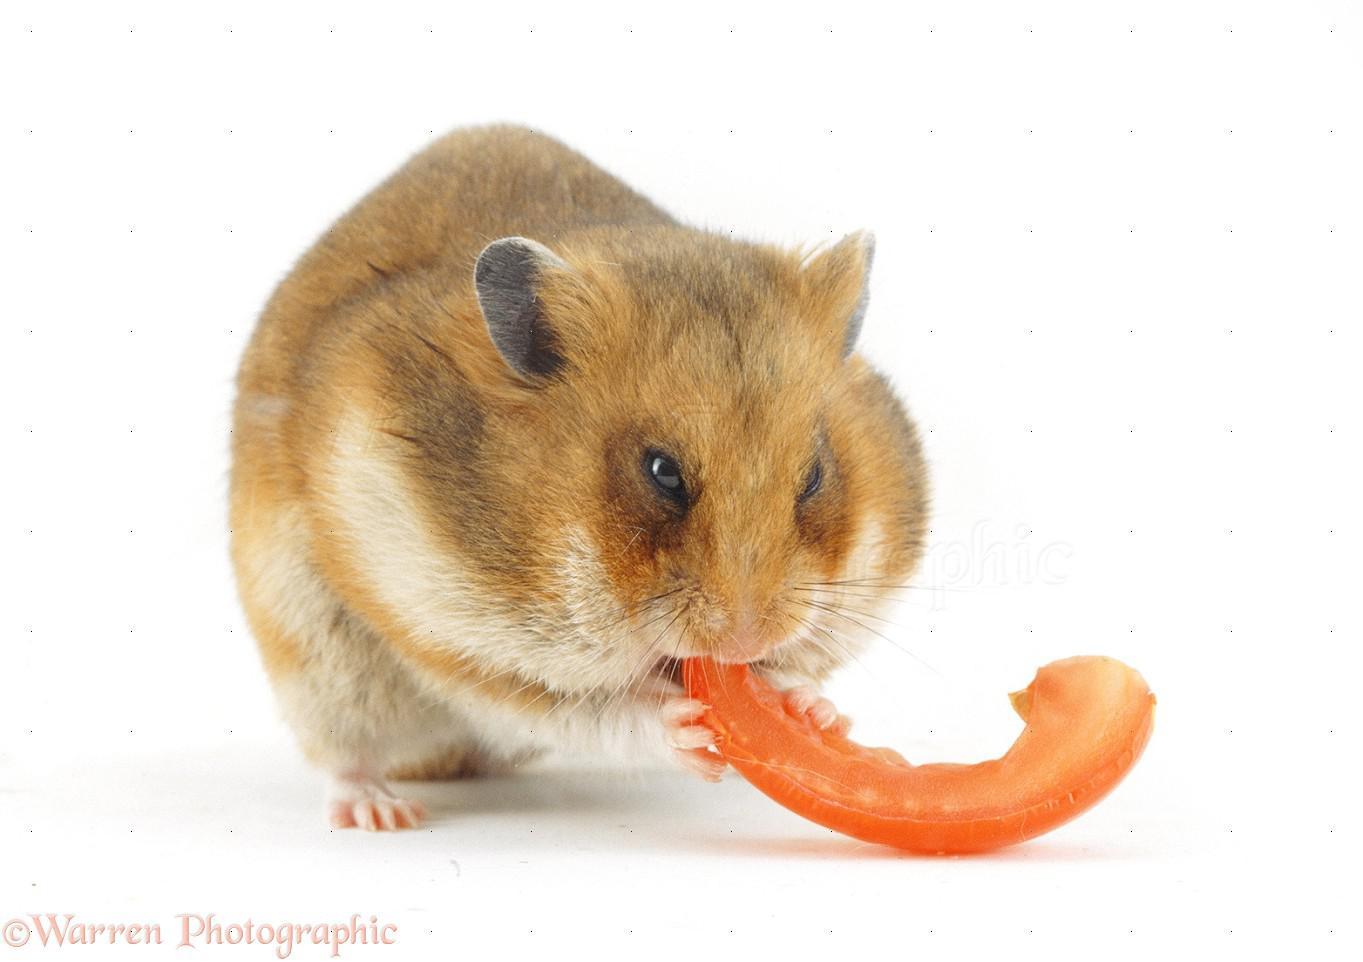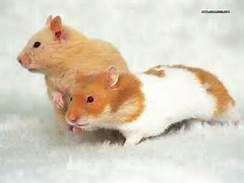The first image is the image on the left, the second image is the image on the right. Assess this claim about the two images: "There are fewer than four hamsters.". Correct or not? Answer yes or no. Yes. The first image is the image on the left, the second image is the image on the right. For the images displayed, is the sentence "In one of the images, there is an orange food item being eaten." factually correct? Answer yes or no. Yes. 